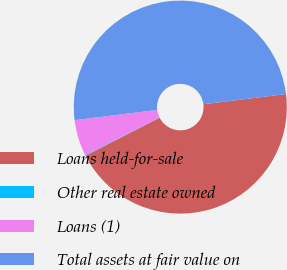Convert chart. <chart><loc_0><loc_0><loc_500><loc_500><pie_chart><fcel>Loans held-for-sale<fcel>Other real estate owned<fcel>Loans (1)<fcel>Total assets at fair value on<nl><fcel>44.4%<fcel>0.1%<fcel>5.5%<fcel>50.0%<nl></chart> 